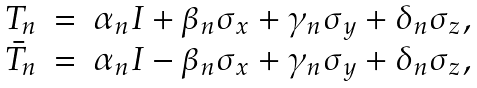<formula> <loc_0><loc_0><loc_500><loc_500>\begin{array} { l l l } T _ { n } & = & \alpha _ { n } I + \beta _ { n } \sigma _ { x } + \gamma _ { n } \sigma _ { y } + \delta _ { n } \sigma _ { z } , \\ \bar { T } _ { n } & = & \alpha _ { n } I - \beta _ { n } \sigma _ { x } + \gamma _ { n } \sigma _ { y } + \delta _ { n } \sigma _ { z } , \end{array}</formula> 